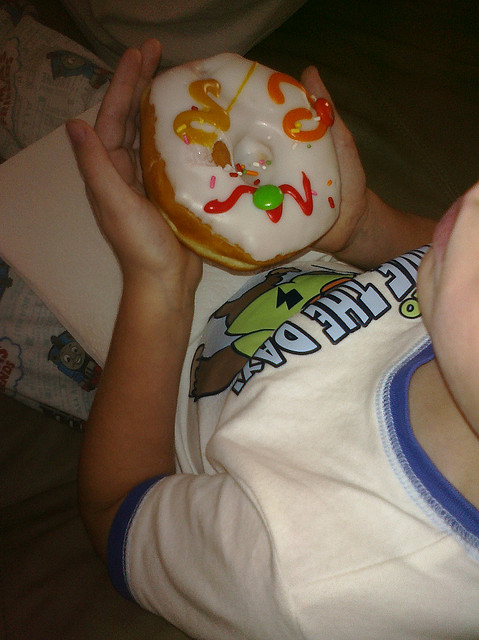Please identify all text content in this image. THE 